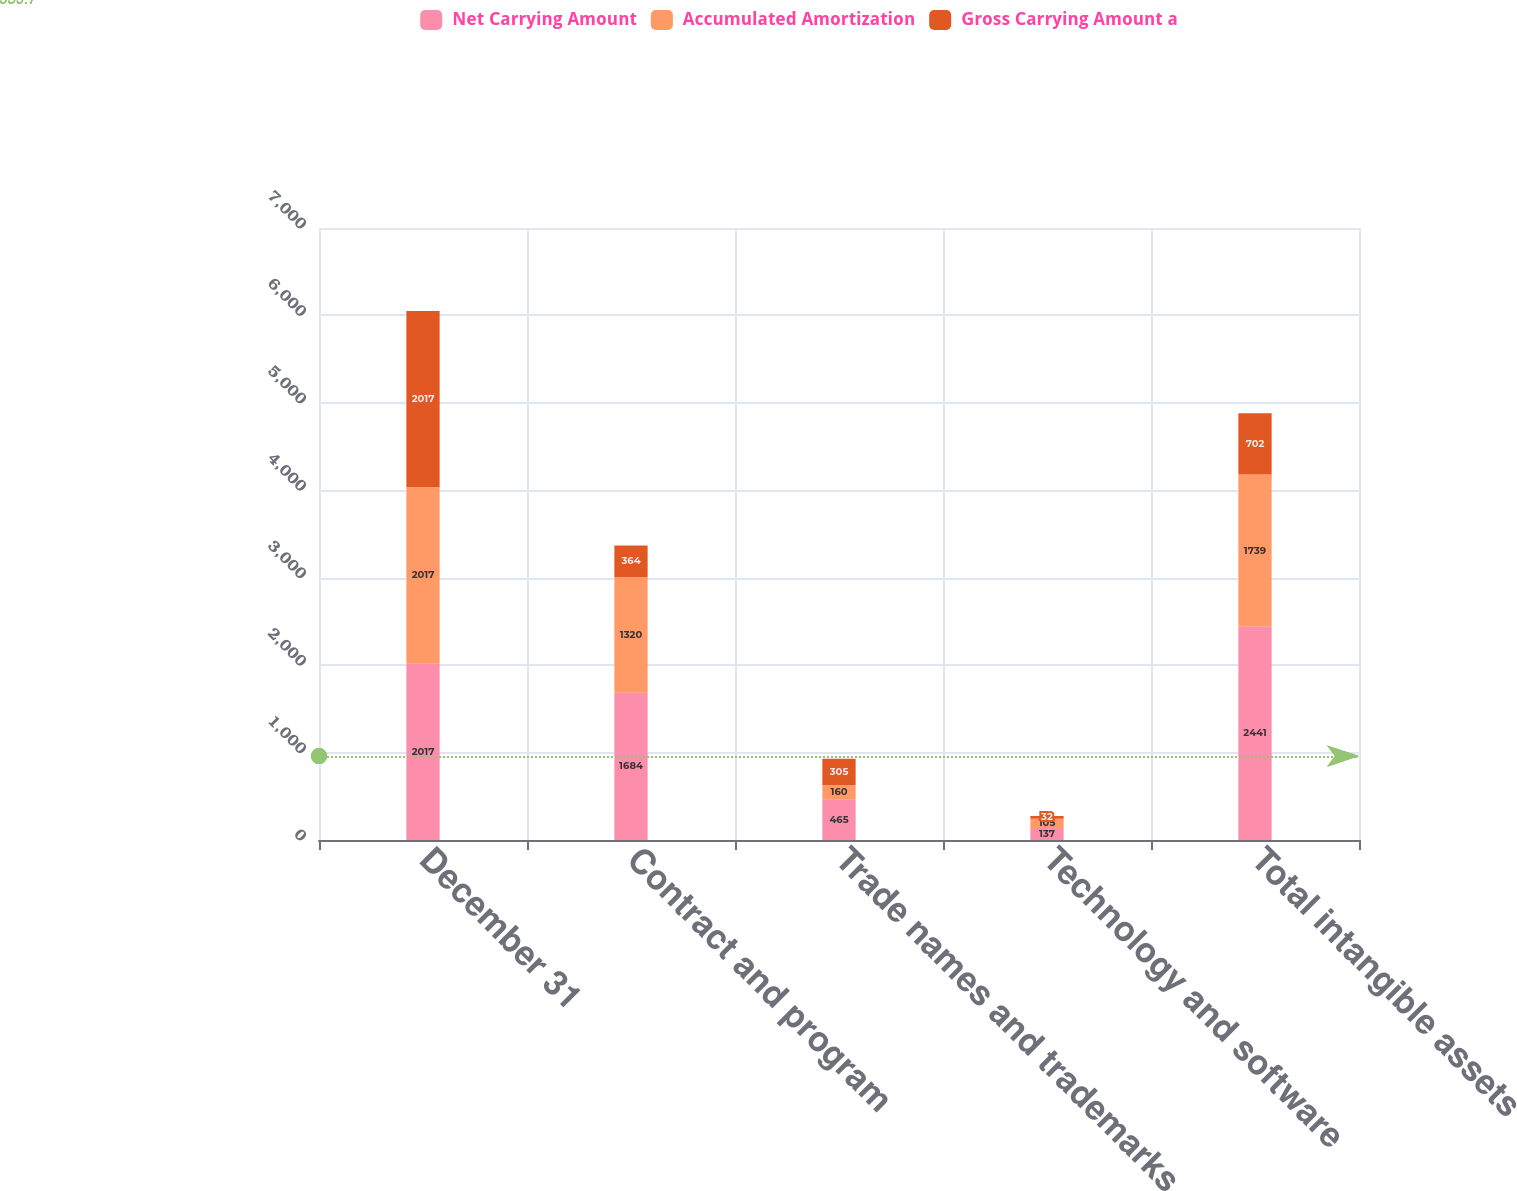Convert chart. <chart><loc_0><loc_0><loc_500><loc_500><stacked_bar_chart><ecel><fcel>December 31<fcel>Contract and program<fcel>Trade names and trademarks<fcel>Technology and software<fcel>Total intangible assets<nl><fcel>Net Carrying Amount<fcel>2017<fcel>1684<fcel>465<fcel>137<fcel>2441<nl><fcel>Accumulated Amortization<fcel>2017<fcel>1320<fcel>160<fcel>105<fcel>1739<nl><fcel>Gross Carrying Amount a<fcel>2017<fcel>364<fcel>305<fcel>32<fcel>702<nl></chart> 